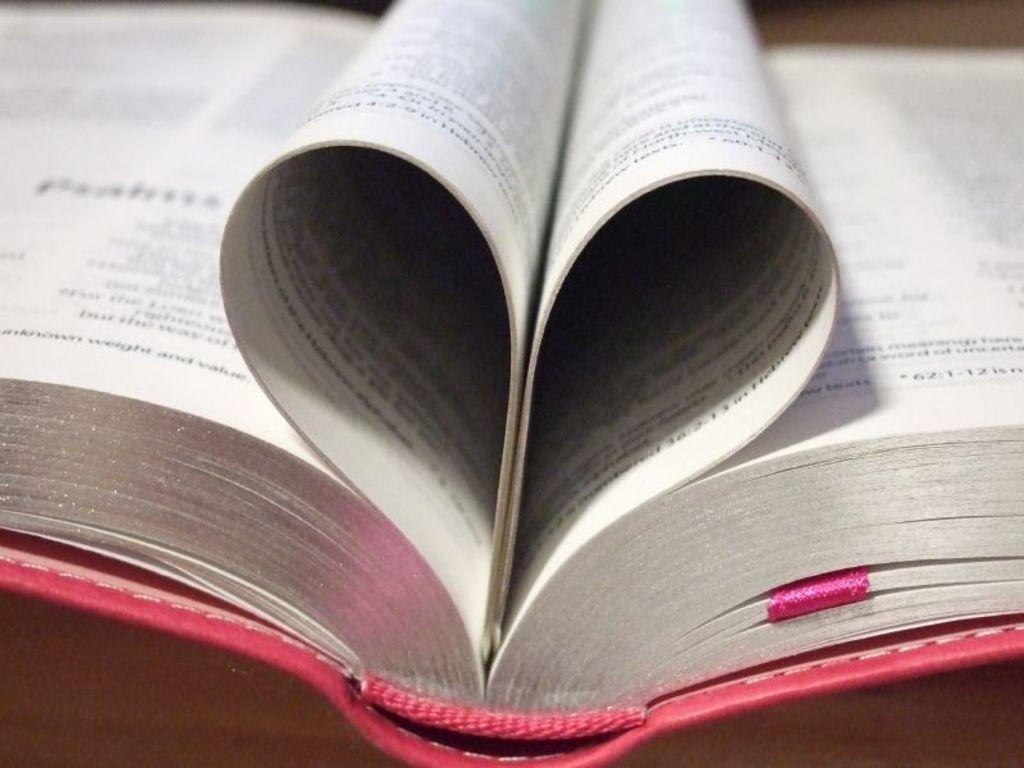<image>
Write a terse but informative summary of the picture. The right side of a page forms a heart shape with the words "in Hebrew" at the bottom. 